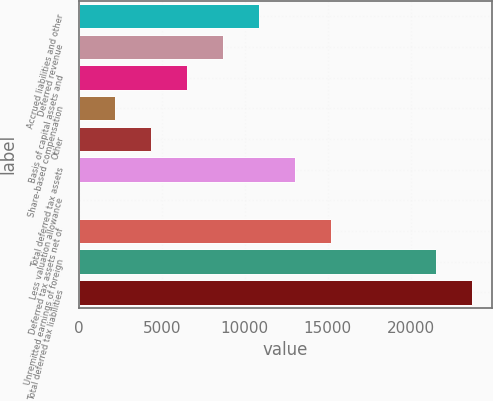Convert chart. <chart><loc_0><loc_0><loc_500><loc_500><bar_chart><fcel>Accrued liabilities and other<fcel>Deferred revenue<fcel>Basis of capital assets and<fcel>Share-based compensation<fcel>Other<fcel>Total deferred tax assets<fcel>Less valuation allowance<fcel>Deferred tax assets net of<fcel>Unremitted earnings of foreign<fcel>Total deferred tax liabilities<nl><fcel>10834.4<fcel>8668.45<fcel>6502.52<fcel>2170.66<fcel>4336.59<fcel>13000.3<fcel>4.73<fcel>15166.2<fcel>21544<fcel>23709.9<nl></chart> 